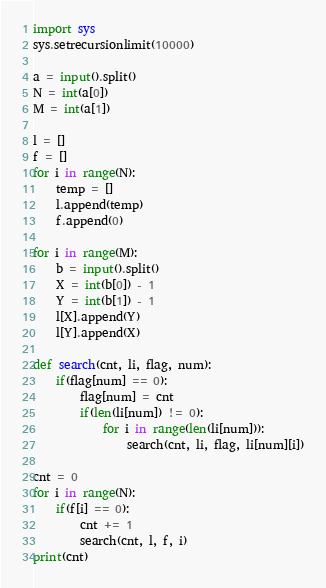<code> <loc_0><loc_0><loc_500><loc_500><_Python_>import sys
sys.setrecursionlimit(10000)

a = input().split()
N = int(a[0])
M = int(a[1])

l = []
f = []
for i in range(N):
	temp = []
	l.append(temp)
	f.append(0)

for i in range(M):
	b = input().split()
	X = int(b[0]) - 1
	Y = int(b[1]) - 1
	l[X].append(Y)
	l[Y].append(X)

def search(cnt, li, flag, num):
	if(flag[num] == 0):
		flag[num] = cnt
		if(len(li[num]) != 0):
			for i in range(len(li[num])):
				search(cnt, li, flag, li[num][i])
		
cnt = 0
for i in range(N):
	if(f[i] == 0):
		cnt += 1
		search(cnt, l, f, i)			
print(cnt)</code> 